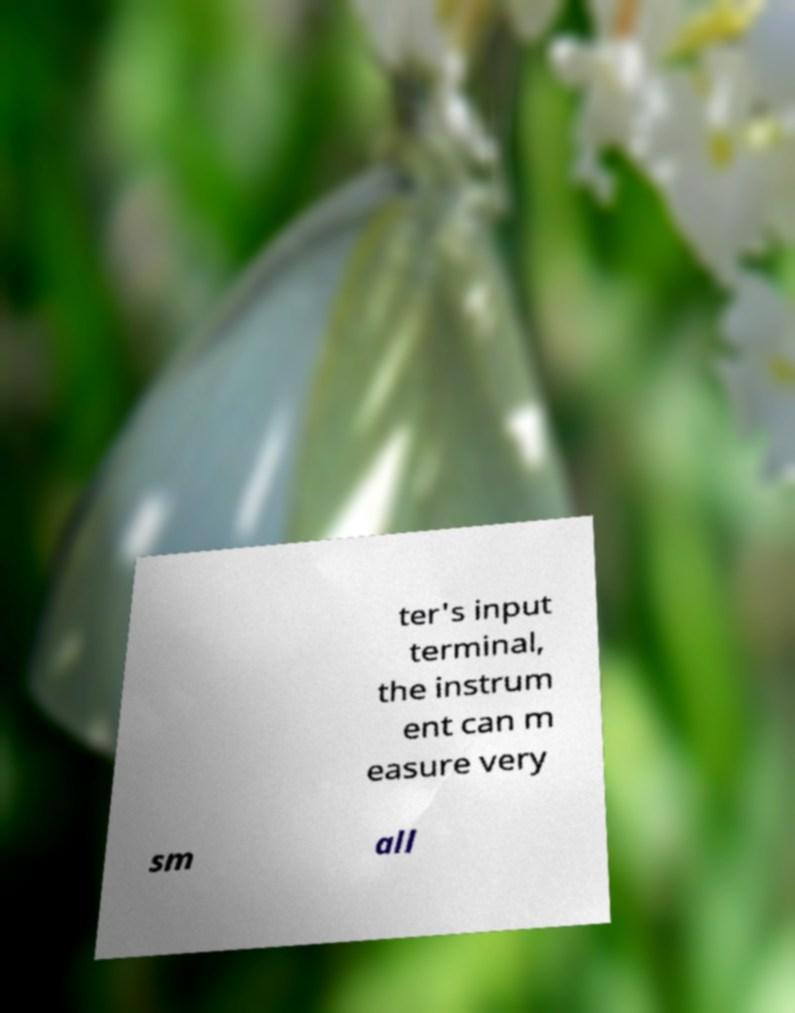Please read and relay the text visible in this image. What does it say? ter's input terminal, the instrum ent can m easure very sm all 